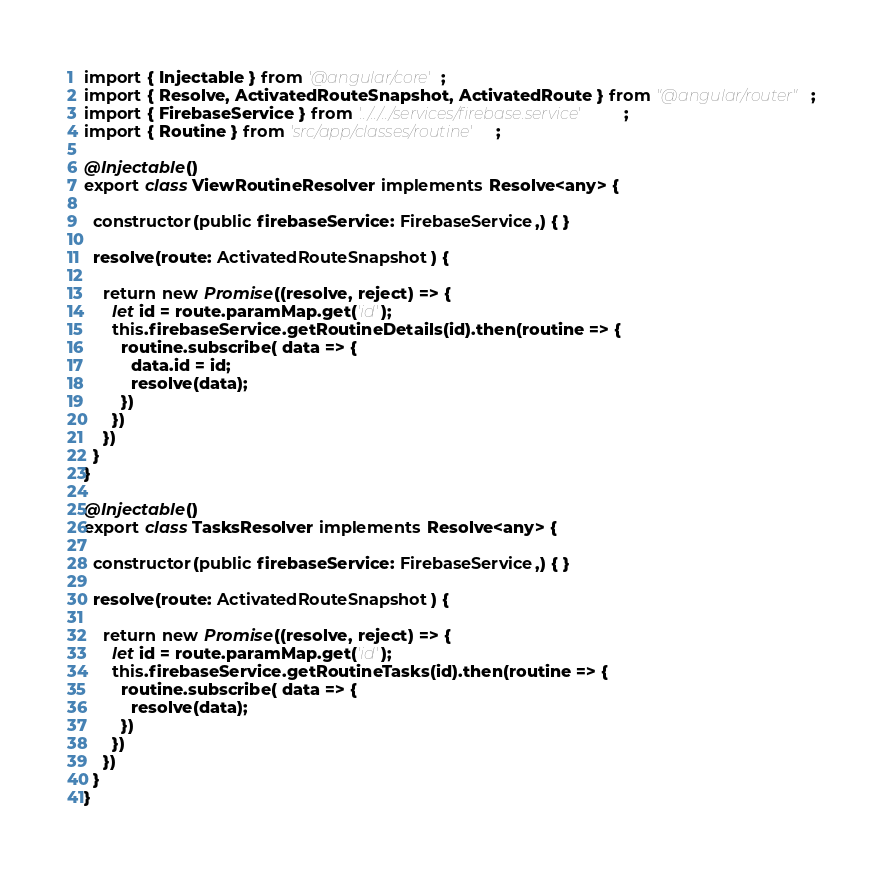<code> <loc_0><loc_0><loc_500><loc_500><_TypeScript_>import { Injectable } from '@angular/core';
import { Resolve, ActivatedRouteSnapshot, ActivatedRoute } from "@angular/router";
import { FirebaseService } from '../../../services/firebase.service';
import { Routine } from 'src/app/classes/routine';

@Injectable()
export class ViewRoutineResolver implements Resolve<any> {

  constructor(public firebaseService: FirebaseService,) { }

  resolve(route: ActivatedRouteSnapshot) {

    return new Promise((resolve, reject) => {
      let id = route.paramMap.get('id');
      this.firebaseService.getRoutineDetails(id).then(routine => {
        routine.subscribe( data => {
          data.id = id;
          resolve(data);
        })
      })
    })
  }
}

@Injectable()
export class TasksResolver implements Resolve<any> {

  constructor(public firebaseService: FirebaseService,) { }

  resolve(route: ActivatedRouteSnapshot) {

    return new Promise((resolve, reject) => {
      let id = route.paramMap.get('id');
      this.firebaseService.getRoutineTasks(id).then(routine => {
        routine.subscribe( data => {
          resolve(data);
        })
      })
    })
  }
}
</code> 